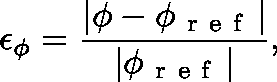Convert formula to latex. <formula><loc_0><loc_0><loc_500><loc_500>\epsilon _ { { \phi } } = \frac { | { \phi } - { \phi } _ { r e f } | } { | { \phi } _ { r e f } | } ,</formula> 